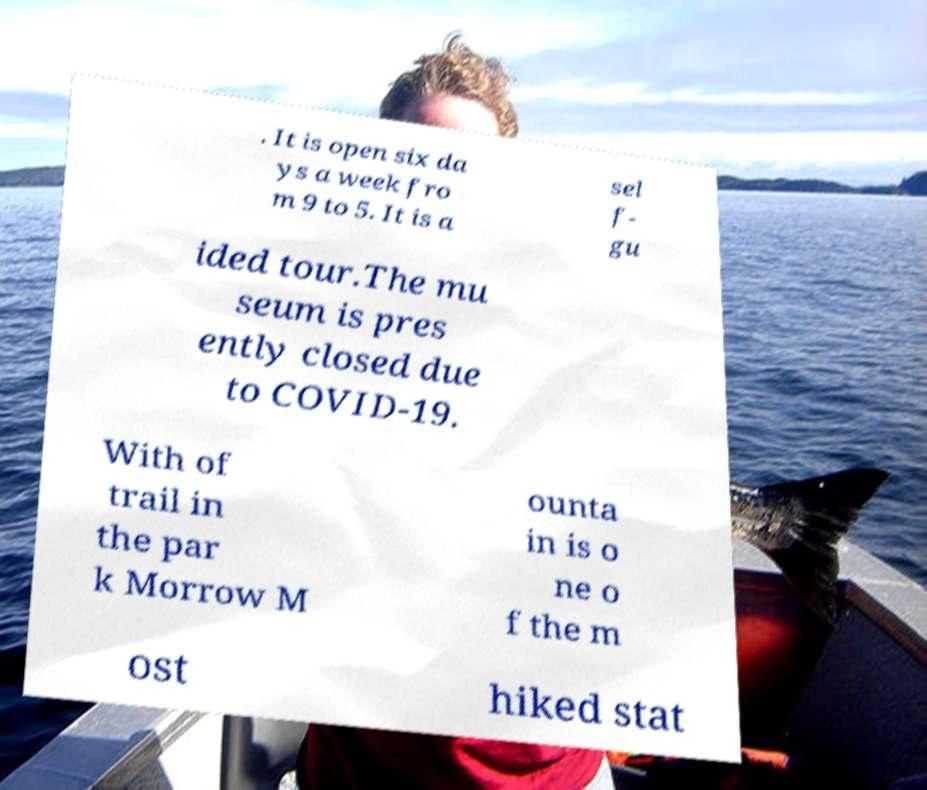Could you assist in decoding the text presented in this image and type it out clearly? . It is open six da ys a week fro m 9 to 5. It is a sel f- gu ided tour.The mu seum is pres ently closed due to COVID-19. With of trail in the par k Morrow M ounta in is o ne o f the m ost hiked stat 